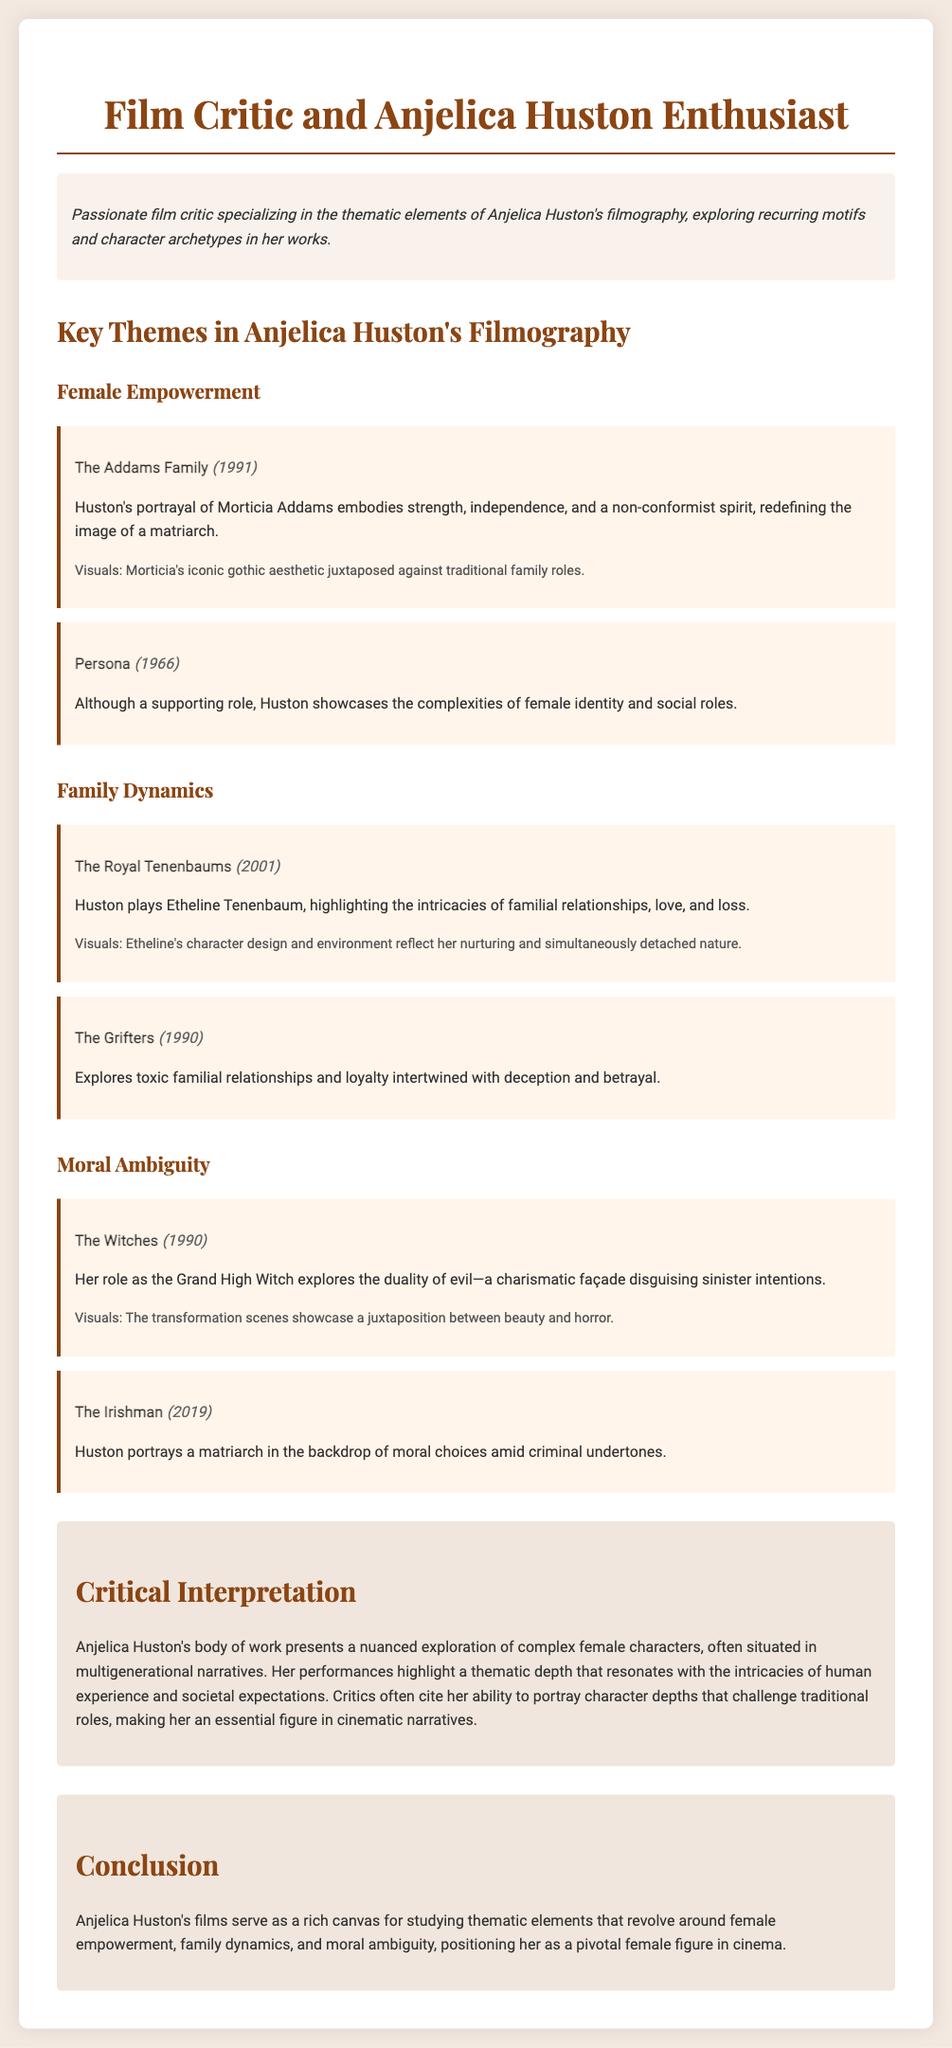What is the title of the document? The title is prominently displayed at the top of the document and is "Film Critic and Anjelica Huston Enthusiast CV."
Answer: Film Critic and Anjelica Huston Enthusiast CV What year was "The Addams Family" released? The release year of "The Addams Family" is mentioned in the example under the Female Empowerment theme.
Answer: 1991 Which theme is associated with the film "The Royal Tenenbaums"? The theme is specified in the section discussing Huston's performance in "The Royal Tenenbaums."
Answer: Family Dynamics What is the main thematic focus of Anjelica Huston's filmography? The document outlines several themes prevalent in her films, indicating a major focus on female empowerment, family dynamics, and moral ambiguity.
Answer: Female Empowerment, Family Dynamics, Moral Ambiguity What role does Anjelica Huston play in "The Witches"? The film is referenced along with Huston's character role in the context of exploring moral ambiguity.
Answer: Grand High Witch In which film does Anjelica Huston showcase complexities of female identity? The film is identified in the examples under the Female Empowerment theme, highlighting Huston's supporting role.
Answer: Persona How does the document describe Huston's performance style? It discusses her ability to portray character depths that challenge traditional roles, indicating her complex performance style.
Answer: Nuanced exploration What is the overarching conclusion about Anjelica Huston's films? The conclusion summarizes her films' thematic richness, highlighting their significance.
Answer: A pivotal female figure in cinema 